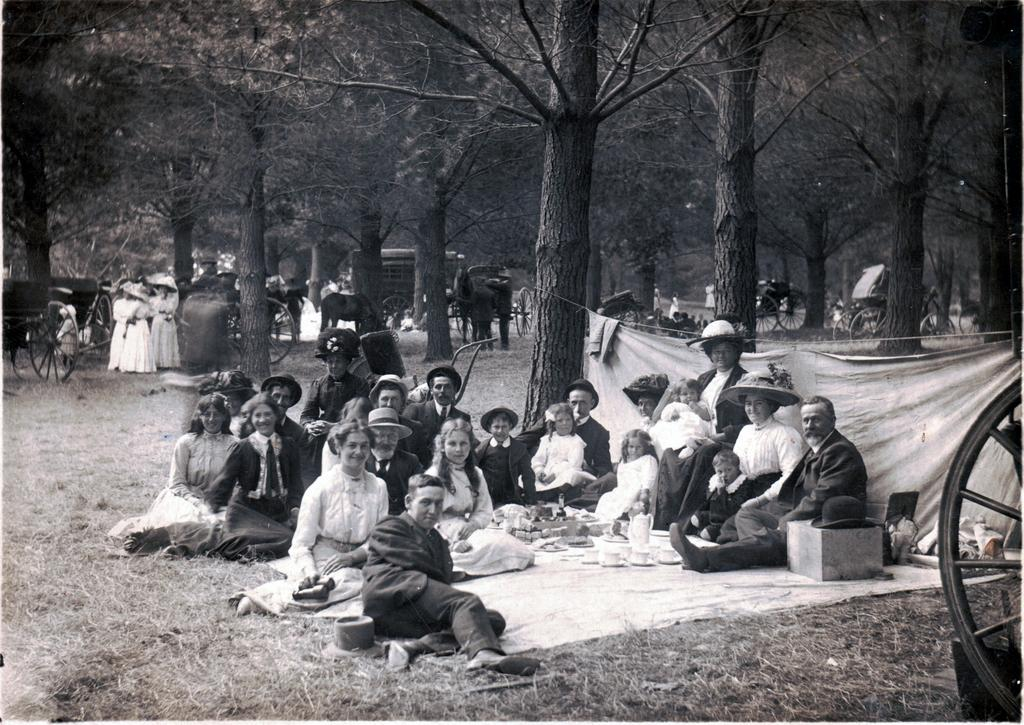What is the color scheme of the image? The image is black and white. What can be seen in the image besides the color scheme? There are persons wearing clothes and horse carts in the image. What are the persons sitting on? The persons are sitting on a cloth. What type of vegetation is present in the image? There are trees in the image. What type of butter is being used to draw on the trees in the image? There is no butter or drawing on the trees in the image; it features persons sitting on a cloth, horse carts, and trees. What color are the crayons that the persons are using to color the horse carts in the image? There are no crayons or coloring of horse carts in the image; it is a black and white image with persons sitting on a cloth, horse carts, and trees. 